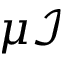Convert formula to latex. <formula><loc_0><loc_0><loc_500><loc_500>\mu \mathcal { I }</formula> 